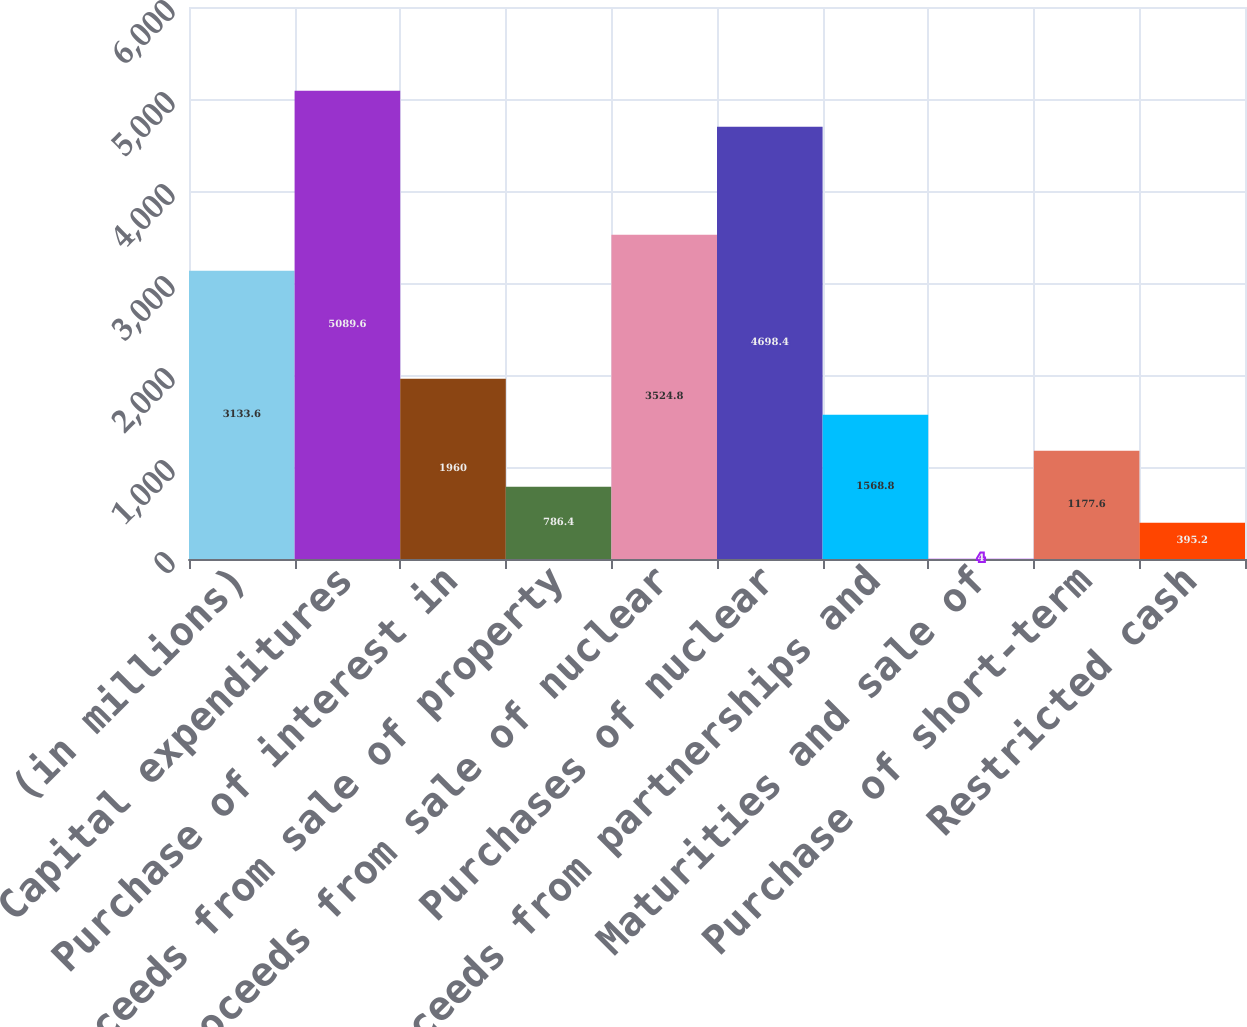<chart> <loc_0><loc_0><loc_500><loc_500><bar_chart><fcel>(in millions)<fcel>Capital expenditures<fcel>Purchase of interest in<fcel>Proceeds from sale of property<fcel>Proceeds from sale of nuclear<fcel>Purchases of nuclear<fcel>Proceeds from partnerships and<fcel>Maturities and sale of<fcel>Purchase of short-term<fcel>Restricted cash<nl><fcel>3133.6<fcel>5089.6<fcel>1960<fcel>786.4<fcel>3524.8<fcel>4698.4<fcel>1568.8<fcel>4<fcel>1177.6<fcel>395.2<nl></chart> 